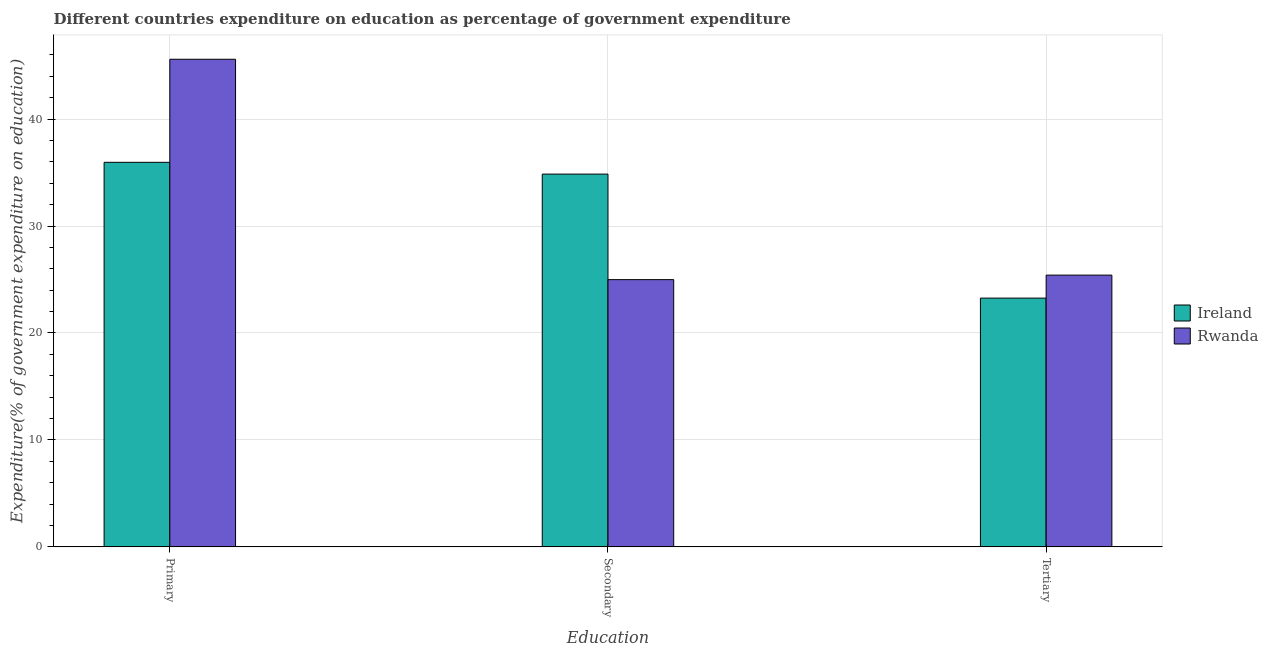How many groups of bars are there?
Your response must be concise. 3. How many bars are there on the 1st tick from the left?
Ensure brevity in your answer.  2. How many bars are there on the 3rd tick from the right?
Provide a short and direct response. 2. What is the label of the 3rd group of bars from the left?
Provide a short and direct response. Tertiary. What is the expenditure on secondary education in Rwanda?
Your answer should be very brief. 24.99. Across all countries, what is the maximum expenditure on tertiary education?
Offer a terse response. 25.41. Across all countries, what is the minimum expenditure on primary education?
Provide a short and direct response. 35.96. In which country was the expenditure on primary education maximum?
Provide a short and direct response. Rwanda. In which country was the expenditure on primary education minimum?
Your response must be concise. Ireland. What is the total expenditure on tertiary education in the graph?
Give a very brief answer. 48.67. What is the difference between the expenditure on secondary education in Rwanda and that in Ireland?
Give a very brief answer. -9.87. What is the difference between the expenditure on secondary education in Ireland and the expenditure on primary education in Rwanda?
Make the answer very short. -10.74. What is the average expenditure on secondary education per country?
Offer a very short reply. 29.92. What is the difference between the expenditure on primary education and expenditure on secondary education in Ireland?
Your answer should be very brief. 1.1. In how many countries, is the expenditure on primary education greater than 24 %?
Make the answer very short. 2. What is the ratio of the expenditure on tertiary education in Rwanda to that in Ireland?
Your response must be concise. 1.09. What is the difference between the highest and the second highest expenditure on primary education?
Make the answer very short. 9.64. What is the difference between the highest and the lowest expenditure on secondary education?
Offer a very short reply. 9.87. What does the 1st bar from the left in Tertiary represents?
Keep it short and to the point. Ireland. What does the 1st bar from the right in Tertiary represents?
Keep it short and to the point. Rwanda. How many countries are there in the graph?
Make the answer very short. 2. What is the difference between two consecutive major ticks on the Y-axis?
Your response must be concise. 10. Are the values on the major ticks of Y-axis written in scientific E-notation?
Offer a very short reply. No. Does the graph contain any zero values?
Offer a very short reply. No. Does the graph contain grids?
Make the answer very short. Yes. How are the legend labels stacked?
Make the answer very short. Vertical. What is the title of the graph?
Offer a very short reply. Different countries expenditure on education as percentage of government expenditure. Does "Sudan" appear as one of the legend labels in the graph?
Ensure brevity in your answer.  No. What is the label or title of the X-axis?
Offer a terse response. Education. What is the label or title of the Y-axis?
Offer a very short reply. Expenditure(% of government expenditure on education). What is the Expenditure(% of government expenditure on education) in Ireland in Primary?
Make the answer very short. 35.96. What is the Expenditure(% of government expenditure on education) in Rwanda in Primary?
Provide a succinct answer. 45.6. What is the Expenditure(% of government expenditure on education) in Ireland in Secondary?
Ensure brevity in your answer.  34.86. What is the Expenditure(% of government expenditure on education) in Rwanda in Secondary?
Provide a short and direct response. 24.99. What is the Expenditure(% of government expenditure on education) of Ireland in Tertiary?
Provide a short and direct response. 23.26. What is the Expenditure(% of government expenditure on education) in Rwanda in Tertiary?
Offer a very short reply. 25.41. Across all Education, what is the maximum Expenditure(% of government expenditure on education) in Ireland?
Offer a terse response. 35.96. Across all Education, what is the maximum Expenditure(% of government expenditure on education) in Rwanda?
Your answer should be compact. 45.6. Across all Education, what is the minimum Expenditure(% of government expenditure on education) in Ireland?
Ensure brevity in your answer.  23.26. Across all Education, what is the minimum Expenditure(% of government expenditure on education) of Rwanda?
Ensure brevity in your answer.  24.99. What is the total Expenditure(% of government expenditure on education) of Ireland in the graph?
Provide a succinct answer. 94.07. What is the total Expenditure(% of government expenditure on education) in Rwanda in the graph?
Your answer should be very brief. 95.99. What is the difference between the Expenditure(% of government expenditure on education) of Ireland in Primary and that in Secondary?
Your answer should be very brief. 1.1. What is the difference between the Expenditure(% of government expenditure on education) in Rwanda in Primary and that in Secondary?
Your answer should be compact. 20.61. What is the difference between the Expenditure(% of government expenditure on education) of Ireland in Primary and that in Tertiary?
Offer a very short reply. 12.7. What is the difference between the Expenditure(% of government expenditure on education) of Rwanda in Primary and that in Tertiary?
Keep it short and to the point. 20.19. What is the difference between the Expenditure(% of government expenditure on education) in Ireland in Secondary and that in Tertiary?
Your answer should be compact. 11.6. What is the difference between the Expenditure(% of government expenditure on education) in Rwanda in Secondary and that in Tertiary?
Provide a succinct answer. -0.42. What is the difference between the Expenditure(% of government expenditure on education) of Ireland in Primary and the Expenditure(% of government expenditure on education) of Rwanda in Secondary?
Offer a very short reply. 10.97. What is the difference between the Expenditure(% of government expenditure on education) of Ireland in Primary and the Expenditure(% of government expenditure on education) of Rwanda in Tertiary?
Give a very brief answer. 10.55. What is the difference between the Expenditure(% of government expenditure on education) of Ireland in Secondary and the Expenditure(% of government expenditure on education) of Rwanda in Tertiary?
Your response must be concise. 9.45. What is the average Expenditure(% of government expenditure on education) in Ireland per Education?
Offer a very short reply. 31.36. What is the average Expenditure(% of government expenditure on education) in Rwanda per Education?
Offer a terse response. 32. What is the difference between the Expenditure(% of government expenditure on education) in Ireland and Expenditure(% of government expenditure on education) in Rwanda in Primary?
Your response must be concise. -9.64. What is the difference between the Expenditure(% of government expenditure on education) of Ireland and Expenditure(% of government expenditure on education) of Rwanda in Secondary?
Your answer should be compact. 9.87. What is the difference between the Expenditure(% of government expenditure on education) in Ireland and Expenditure(% of government expenditure on education) in Rwanda in Tertiary?
Make the answer very short. -2.15. What is the ratio of the Expenditure(% of government expenditure on education) in Ireland in Primary to that in Secondary?
Offer a terse response. 1.03. What is the ratio of the Expenditure(% of government expenditure on education) of Rwanda in Primary to that in Secondary?
Provide a succinct answer. 1.82. What is the ratio of the Expenditure(% of government expenditure on education) in Ireland in Primary to that in Tertiary?
Your answer should be compact. 1.55. What is the ratio of the Expenditure(% of government expenditure on education) in Rwanda in Primary to that in Tertiary?
Offer a very short reply. 1.79. What is the ratio of the Expenditure(% of government expenditure on education) of Ireland in Secondary to that in Tertiary?
Your answer should be very brief. 1.5. What is the ratio of the Expenditure(% of government expenditure on education) in Rwanda in Secondary to that in Tertiary?
Offer a terse response. 0.98. What is the difference between the highest and the second highest Expenditure(% of government expenditure on education) of Ireland?
Provide a short and direct response. 1.1. What is the difference between the highest and the second highest Expenditure(% of government expenditure on education) in Rwanda?
Keep it short and to the point. 20.19. What is the difference between the highest and the lowest Expenditure(% of government expenditure on education) of Ireland?
Keep it short and to the point. 12.7. What is the difference between the highest and the lowest Expenditure(% of government expenditure on education) of Rwanda?
Your answer should be compact. 20.61. 